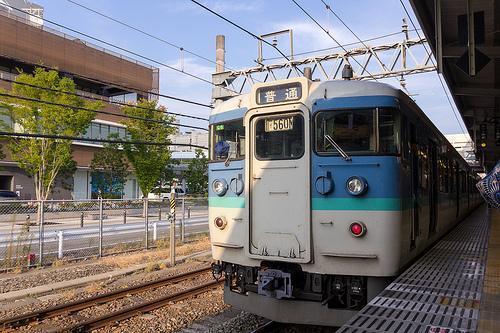How many trees are there?
Give a very brief answer. 4. 